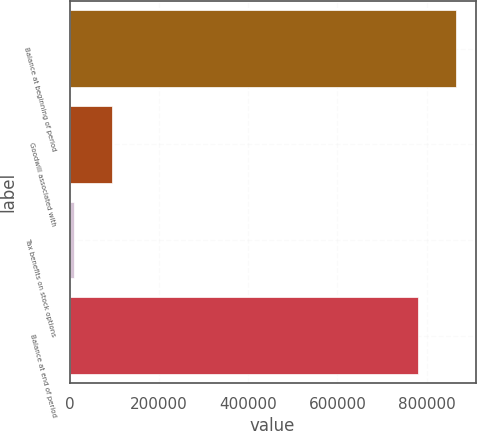<chart> <loc_0><loc_0><loc_500><loc_500><bar_chart><fcel>Balance at beginning of period<fcel>Goodwill associated with<fcel>Tax benefits on stock options<fcel>Balance at end of period<nl><fcel>866648<fcel>94646.9<fcel>9289<fcel>781290<nl></chart> 